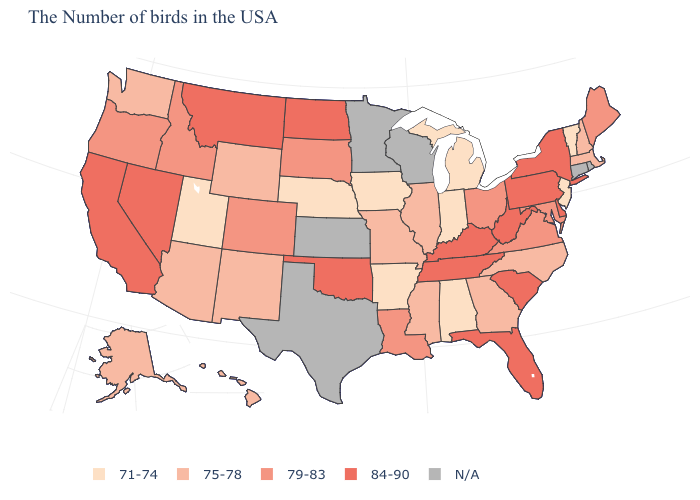What is the lowest value in states that border Nebraska?
Write a very short answer. 71-74. What is the lowest value in the USA?
Quick response, please. 71-74. Name the states that have a value in the range 75-78?
Be succinct. Massachusetts, New Hampshire, North Carolina, Georgia, Illinois, Mississippi, Missouri, Wyoming, New Mexico, Arizona, Washington, Alaska, Hawaii. How many symbols are there in the legend?
Write a very short answer. 5. Among the states that border Iowa , which have the lowest value?
Give a very brief answer. Nebraska. Name the states that have a value in the range 75-78?
Short answer required. Massachusetts, New Hampshire, North Carolina, Georgia, Illinois, Mississippi, Missouri, Wyoming, New Mexico, Arizona, Washington, Alaska, Hawaii. What is the highest value in the MidWest ?
Answer briefly. 84-90. Which states have the lowest value in the Northeast?
Keep it brief. Vermont, New Jersey. What is the highest value in the USA?
Concise answer only. 84-90. Name the states that have a value in the range 79-83?
Short answer required. Maine, Maryland, Virginia, Ohio, Louisiana, South Dakota, Colorado, Idaho, Oregon. What is the highest value in states that border Vermont?
Be succinct. 84-90. What is the value of Alaska?
Short answer required. 75-78. What is the highest value in states that border Pennsylvania?
Write a very short answer. 84-90. What is the value of Kentucky?
Short answer required. 84-90. Name the states that have a value in the range 84-90?
Give a very brief answer. New York, Delaware, Pennsylvania, South Carolina, West Virginia, Florida, Kentucky, Tennessee, Oklahoma, North Dakota, Montana, Nevada, California. 